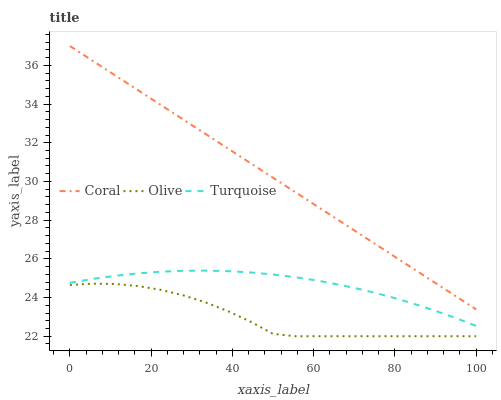Does Olive have the minimum area under the curve?
Answer yes or no. Yes. Does Coral have the maximum area under the curve?
Answer yes or no. Yes. Does Turquoise have the minimum area under the curve?
Answer yes or no. No. Does Turquoise have the maximum area under the curve?
Answer yes or no. No. Is Coral the smoothest?
Answer yes or no. Yes. Is Olive the roughest?
Answer yes or no. Yes. Is Turquoise the smoothest?
Answer yes or no. No. Is Turquoise the roughest?
Answer yes or no. No. Does Turquoise have the lowest value?
Answer yes or no. No. Does Coral have the highest value?
Answer yes or no. Yes. Does Turquoise have the highest value?
Answer yes or no. No. Is Olive less than Coral?
Answer yes or no. Yes. Is Turquoise greater than Olive?
Answer yes or no. Yes. Does Olive intersect Coral?
Answer yes or no. No. 